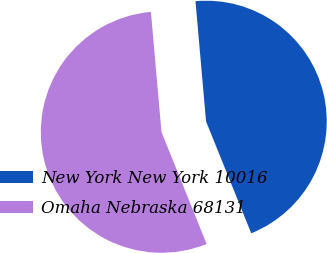<chart> <loc_0><loc_0><loc_500><loc_500><pie_chart><fcel>New York New York 10016<fcel>Omaha Nebraska 68131<nl><fcel>45.29%<fcel>54.71%<nl></chart> 